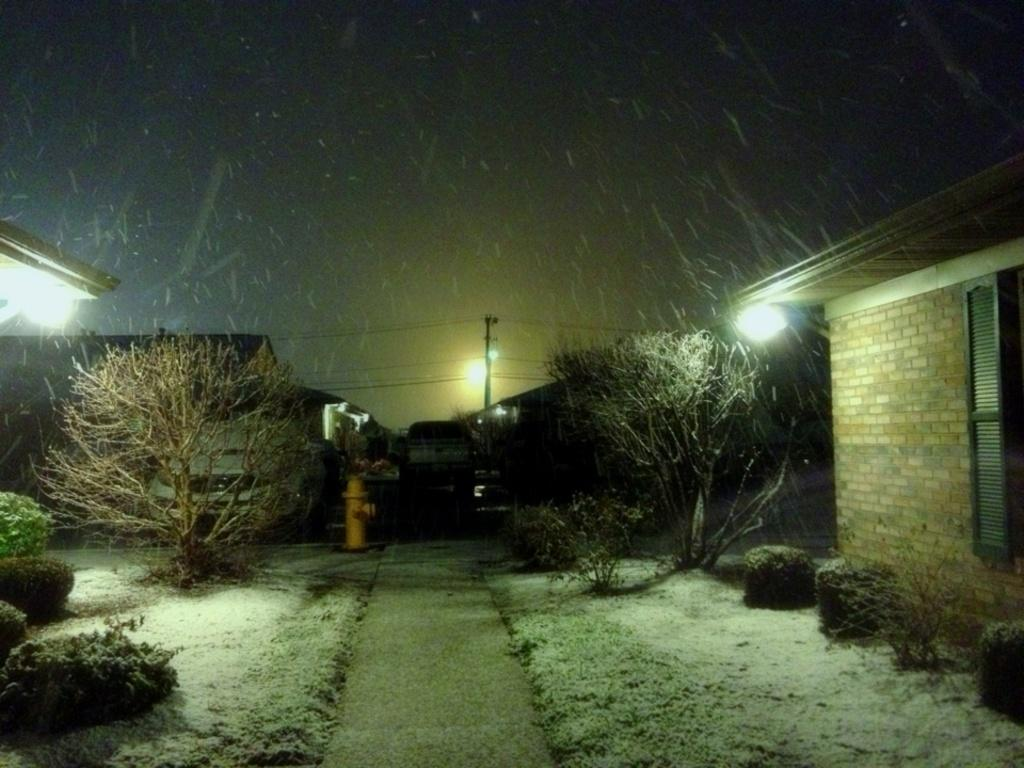What is happening in the foreground of the image? There is a vehicle moving on the road in the foreground of the image. What natural element can be seen in the image? There is a tree visible in the image. What type of man-made structures are present in the image? There are buildings present in the image. What are the poles used for in the image? The poles are likely used for supporting wires or signs in the image. What type of vegetation is present on either side of the road? Plants are present on either side of the road. What is visible at the top of the image? The sky is visible at the top of the image. Can you see your friend flying in the sky in the image? There is no friend flying in the sky in the image; the sky is clear and no aircraft or people are visible. 